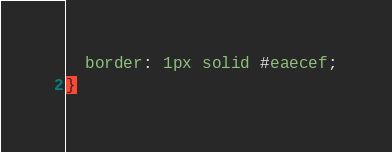<code> <loc_0><loc_0><loc_500><loc_500><_CSS_>  border: 1px solid #eaecef;
}
</code> 